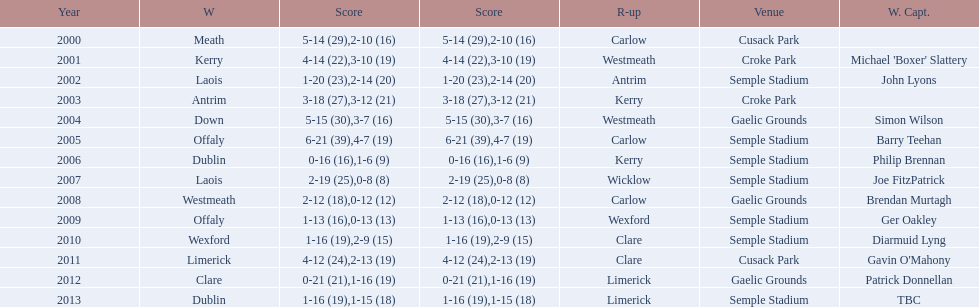How many winners won in semple stadium? 7. 